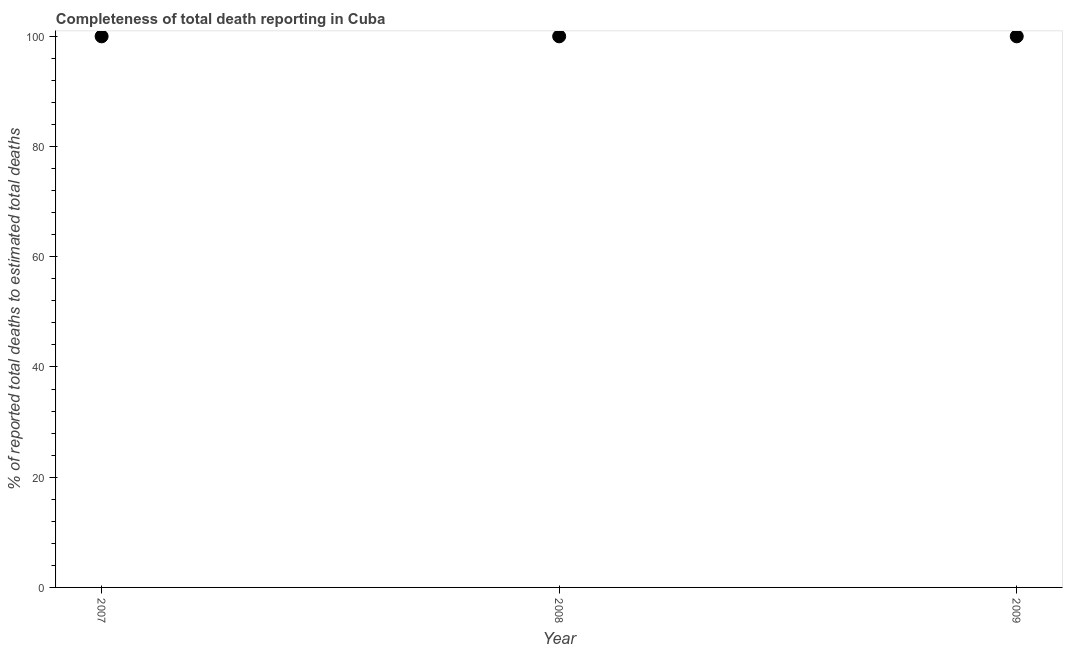What is the completeness of total death reports in 2008?
Your answer should be compact. 100. Across all years, what is the maximum completeness of total death reports?
Make the answer very short. 100. Across all years, what is the minimum completeness of total death reports?
Provide a short and direct response. 100. What is the sum of the completeness of total death reports?
Keep it short and to the point. 300. Do a majority of the years between 2009 and 2008 (inclusive) have completeness of total death reports greater than 64 %?
Your answer should be compact. No. What is the ratio of the completeness of total death reports in 2007 to that in 2009?
Give a very brief answer. 1. Is the difference between the completeness of total death reports in 2007 and 2008 greater than the difference between any two years?
Offer a very short reply. Yes. What is the difference between the highest and the second highest completeness of total death reports?
Offer a very short reply. 0. Is the sum of the completeness of total death reports in 2007 and 2009 greater than the maximum completeness of total death reports across all years?
Provide a short and direct response. Yes. What is the difference between the highest and the lowest completeness of total death reports?
Provide a succinct answer. 0. How many years are there in the graph?
Provide a short and direct response. 3. Are the values on the major ticks of Y-axis written in scientific E-notation?
Give a very brief answer. No. Does the graph contain any zero values?
Keep it short and to the point. No. What is the title of the graph?
Your answer should be very brief. Completeness of total death reporting in Cuba. What is the label or title of the X-axis?
Your answer should be compact. Year. What is the label or title of the Y-axis?
Your answer should be compact. % of reported total deaths to estimated total deaths. What is the % of reported total deaths to estimated total deaths in 2007?
Ensure brevity in your answer.  100. What is the difference between the % of reported total deaths to estimated total deaths in 2007 and 2009?
Make the answer very short. 0. What is the ratio of the % of reported total deaths to estimated total deaths in 2008 to that in 2009?
Keep it short and to the point. 1. 